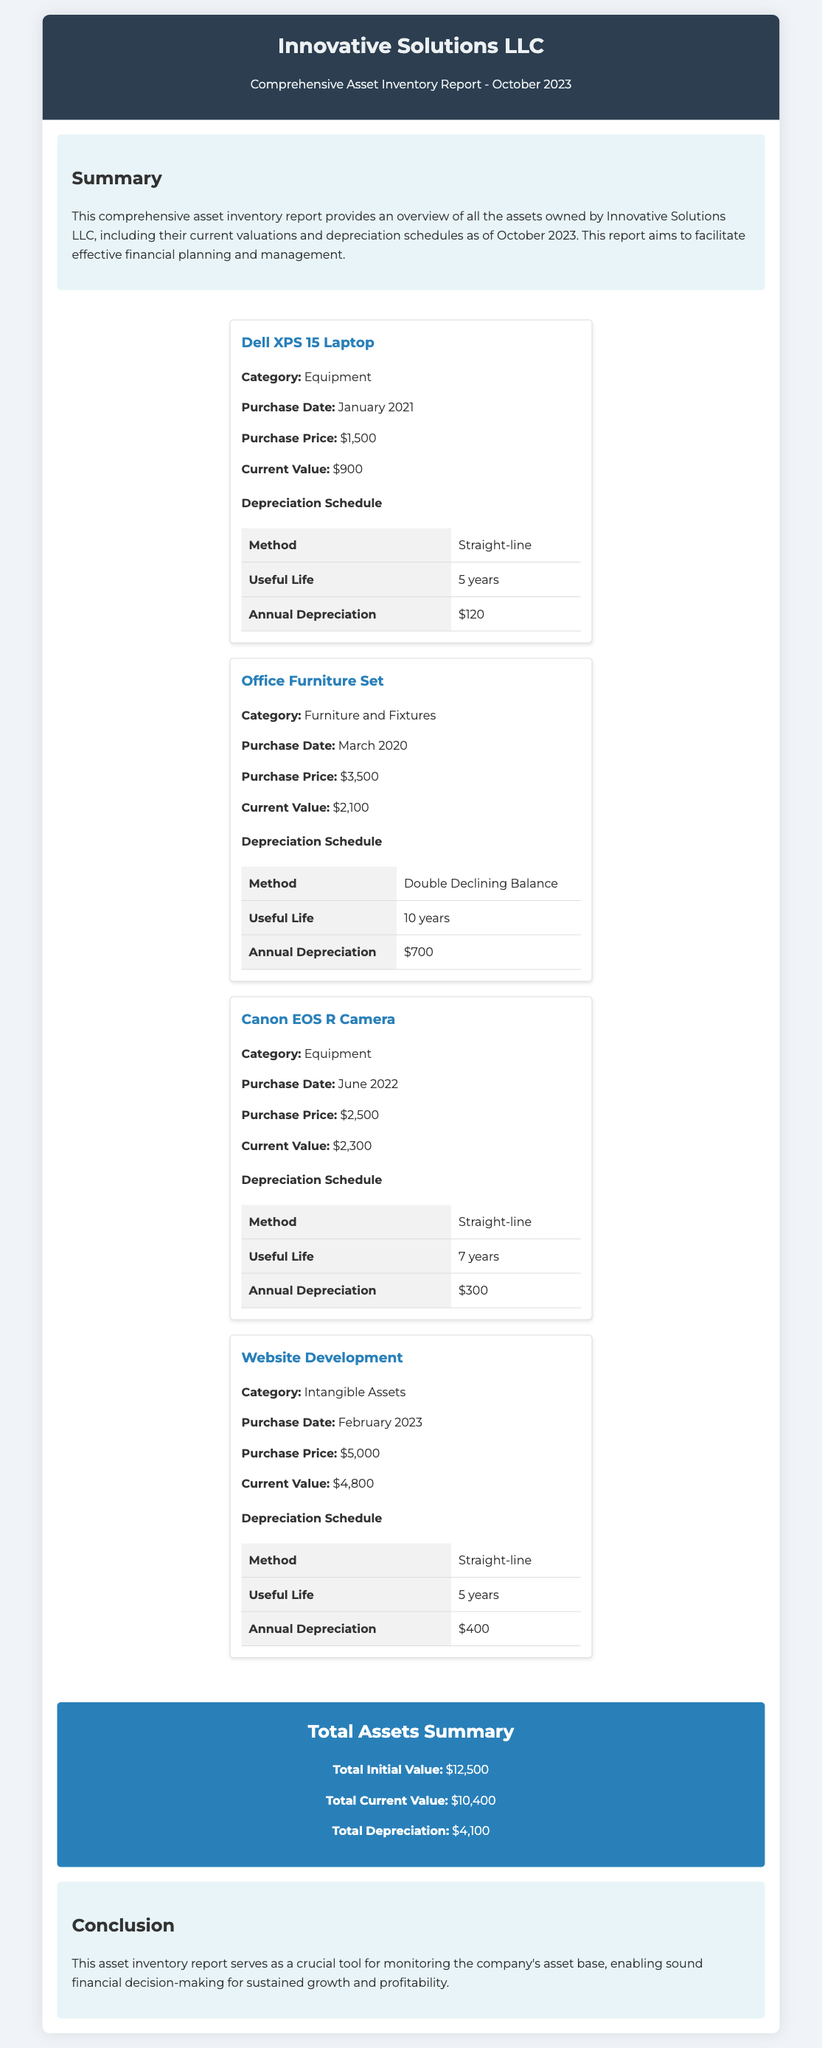What is the purchase price of the Dell XPS 15 Laptop? The document states that the purchase price of the Dell XPS 15 Laptop is $1,500.
Answer: $1,500 What is the current value of the Office Furniture Set? According to the document, the current value of the Office Furniture Set is $2,100.
Answer: $2,100 What depreciation method is used for the Canon EOS R Camera? The document lists the depreciation method for the Canon EOS R Camera as Straight-line.
Answer: Straight-line What is the total current value of all assets? The total current value is presented as $10,400 in the document.
Answer: $10,400 What is the total depreciation for the assets listed? The document states that the total depreciation for the assets is $4,100.
Answer: $4,100 How many years is the useful life for the Website Development? The useful life for the Website Development is specified as 5 years in the document.
Answer: 5 years What category does the Dell XPS 15 Laptop fall under? The Dell XPS 15 Laptop is categorized as Equipment within the document.
Answer: Equipment Which asset has the highest current value? The Canon EOS R Camera has the highest current value of $2,300 as mentioned in the document.
Answer: $2,300 What is the purpose of the comprehensive asset inventory report? The document states that the purpose is to facilitate effective financial planning and management.
Answer: Effective financial planning and management 